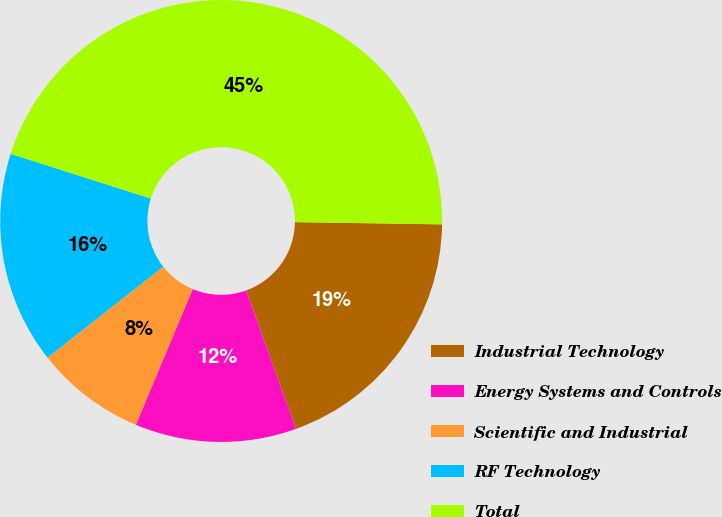<chart> <loc_0><loc_0><loc_500><loc_500><pie_chart><fcel>Industrial Technology<fcel>Energy Systems and Controls<fcel>Scientific and Industrial<fcel>RF Technology<fcel>Total<nl><fcel>19.26%<fcel>11.81%<fcel>8.08%<fcel>15.53%<fcel>45.33%<nl></chart> 